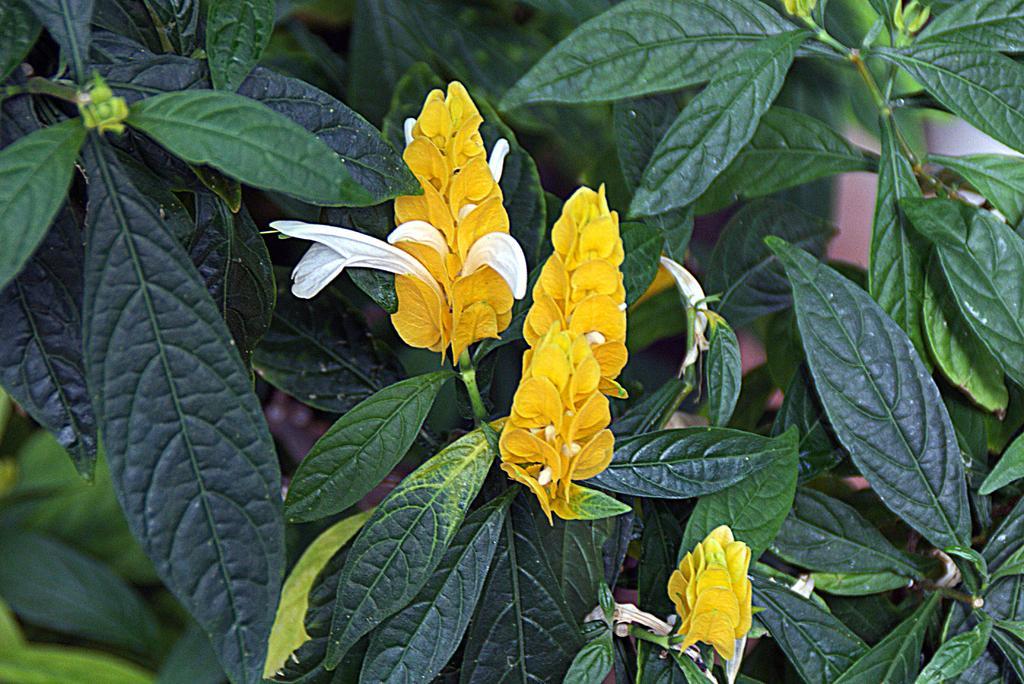In one or two sentences, can you explain what this image depicts? Here in this picture we can see flowers present on plants. 